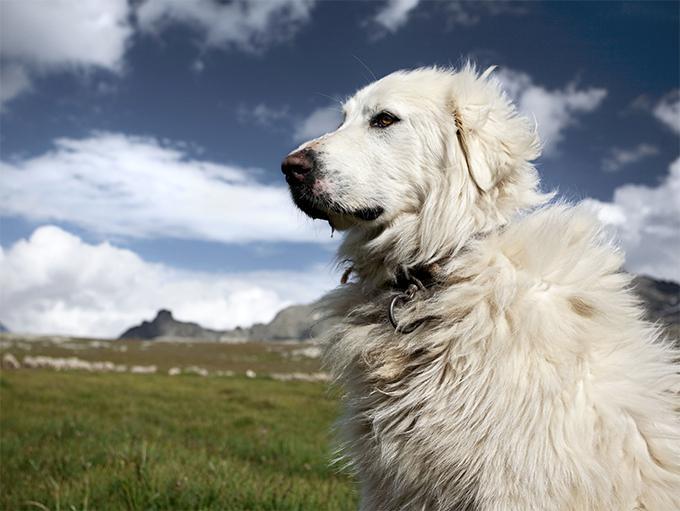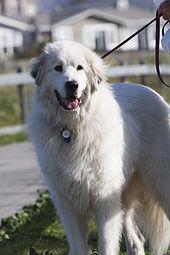The first image is the image on the left, the second image is the image on the right. Considering the images on both sides, is "There is a total of four dogs." valid? Answer yes or no. No. 